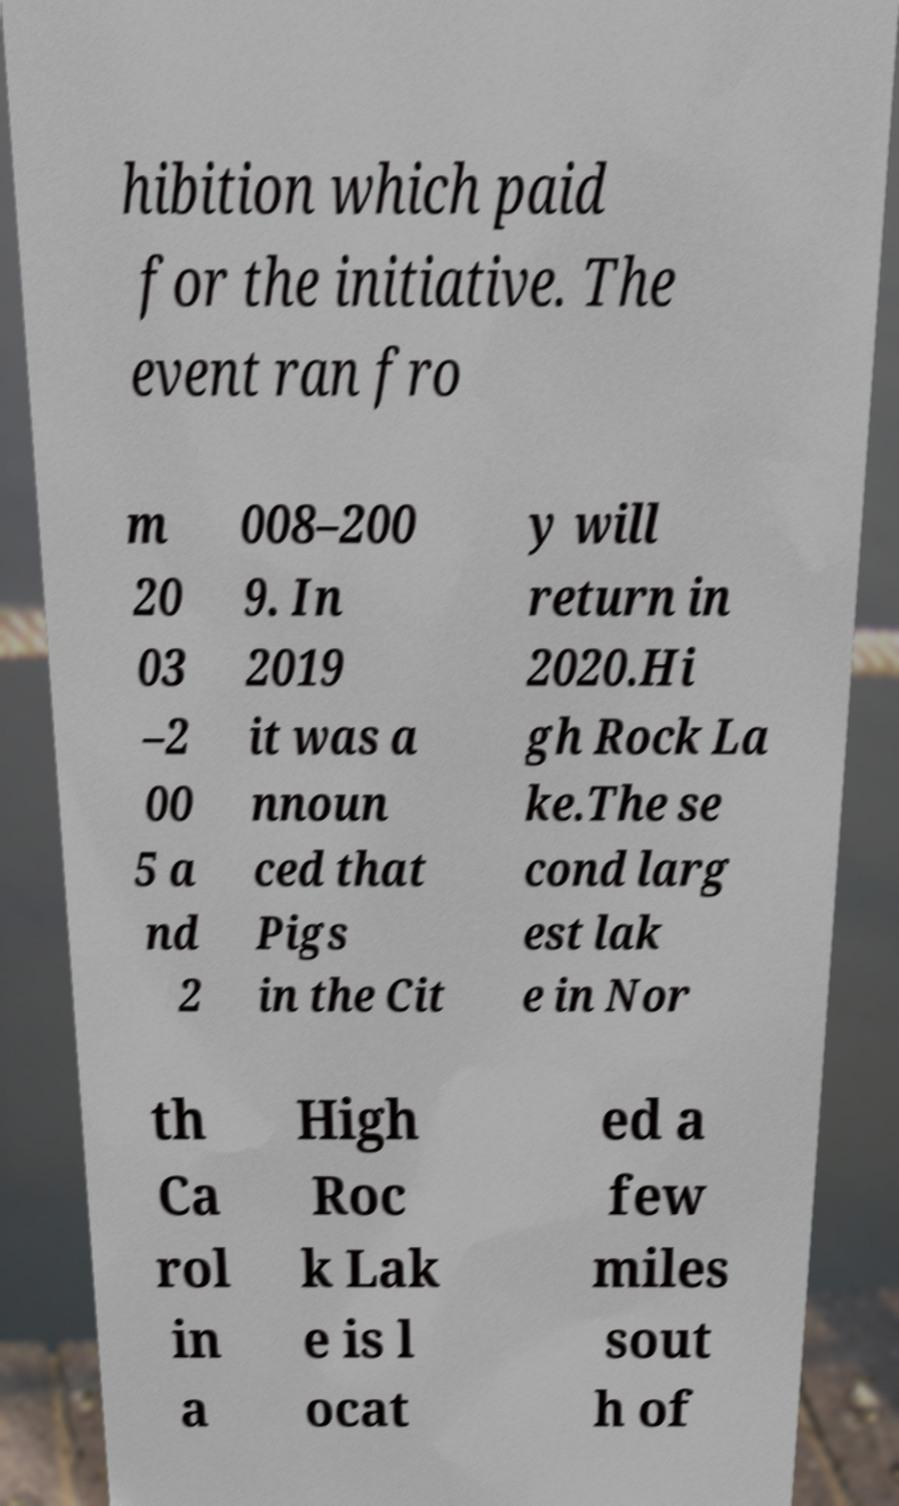Can you read and provide the text displayed in the image?This photo seems to have some interesting text. Can you extract and type it out for me? hibition which paid for the initiative. The event ran fro m 20 03 –2 00 5 a nd 2 008–200 9. In 2019 it was a nnoun ced that Pigs in the Cit y will return in 2020.Hi gh Rock La ke.The se cond larg est lak e in Nor th Ca rol in a High Roc k Lak e is l ocat ed a few miles sout h of 